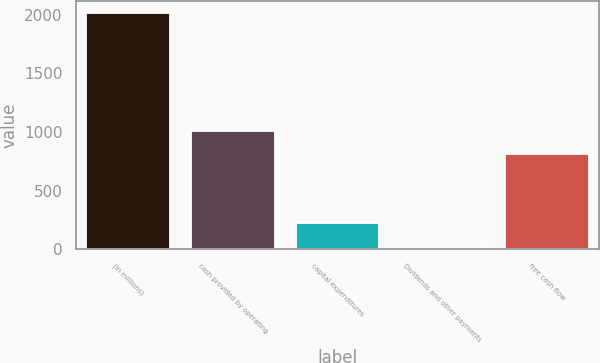Convert chart to OTSL. <chart><loc_0><loc_0><loc_500><loc_500><bar_chart><fcel>(in millions)<fcel>cash provided by operating<fcel>capital expenditures<fcel>Dividends and other payments<fcel>free cash flow<nl><fcel>2011<fcel>1007.8<fcel>221.8<fcel>23<fcel>809<nl></chart> 